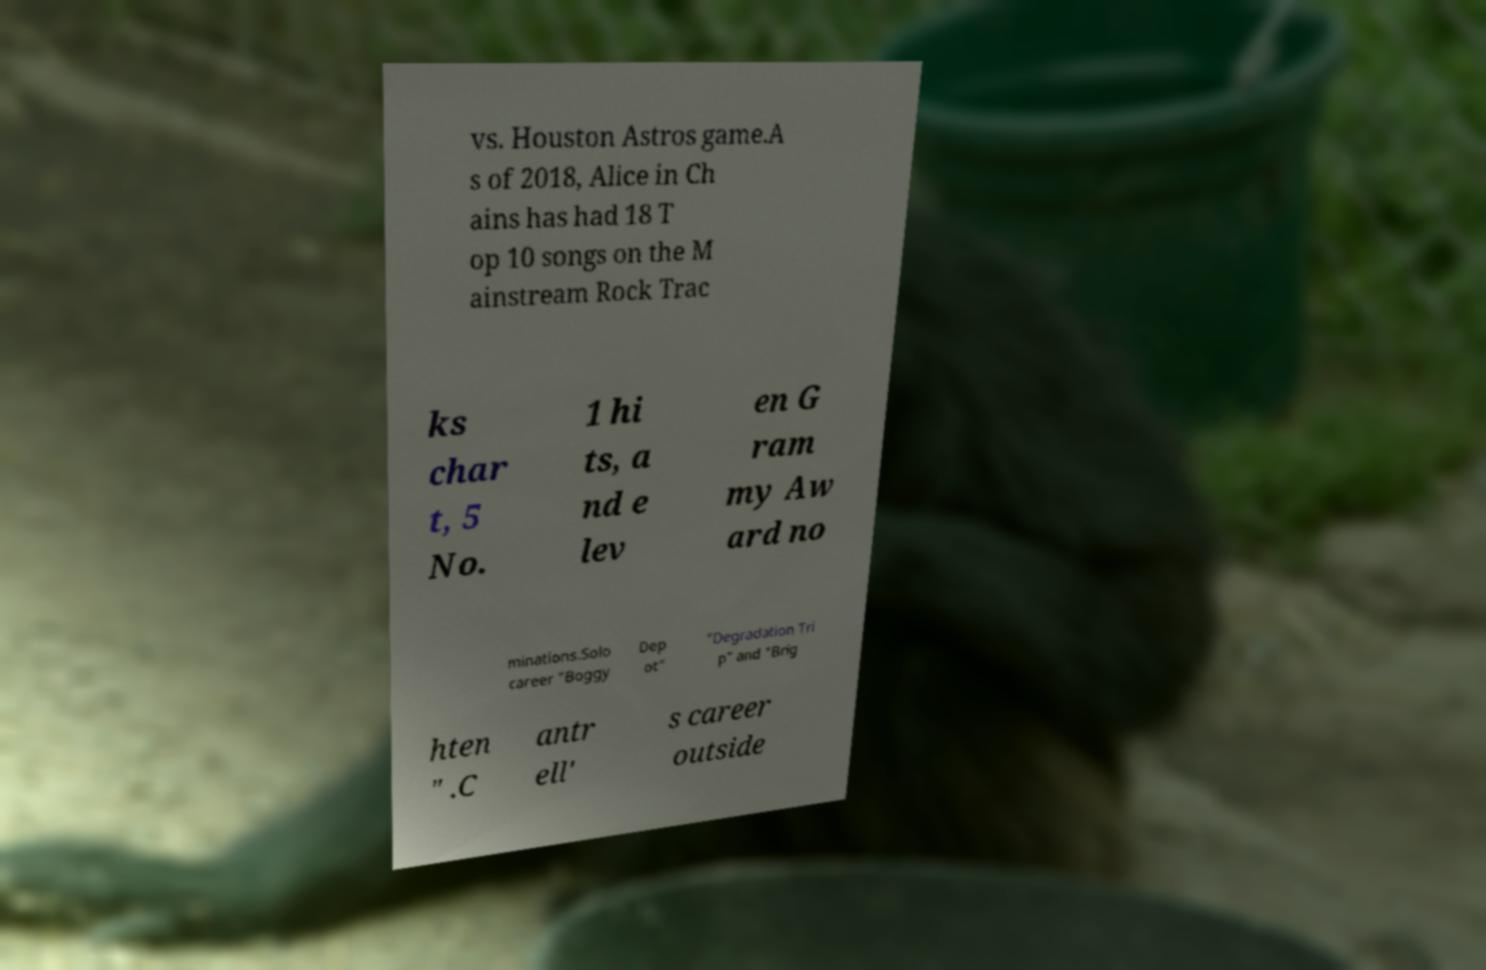There's text embedded in this image that I need extracted. Can you transcribe it verbatim? vs. Houston Astros game.A s of 2018, Alice in Ch ains has had 18 T op 10 songs on the M ainstream Rock Trac ks char t, 5 No. 1 hi ts, a nd e lev en G ram my Aw ard no minations.Solo career "Boggy Dep ot" "Degradation Tri p" and "Brig hten " .C antr ell' s career outside 